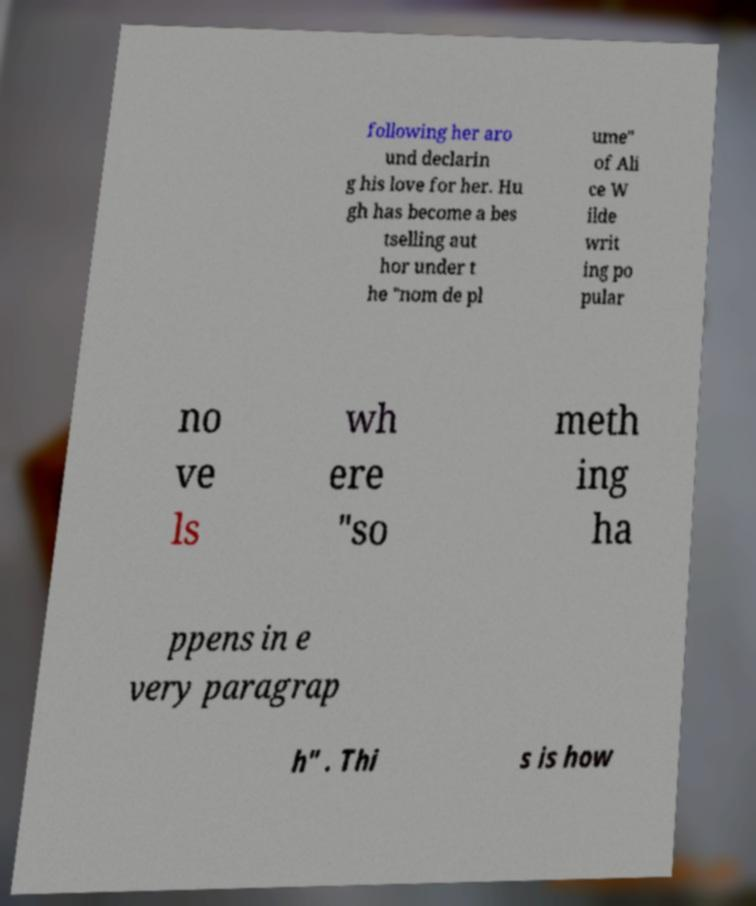There's text embedded in this image that I need extracted. Can you transcribe it verbatim? following her aro und declarin g his love for her. Hu gh has become a bes tselling aut hor under t he "nom de pl ume" of Ali ce W ilde writ ing po pular no ve ls wh ere "so meth ing ha ppens in e very paragrap h" . Thi s is how 